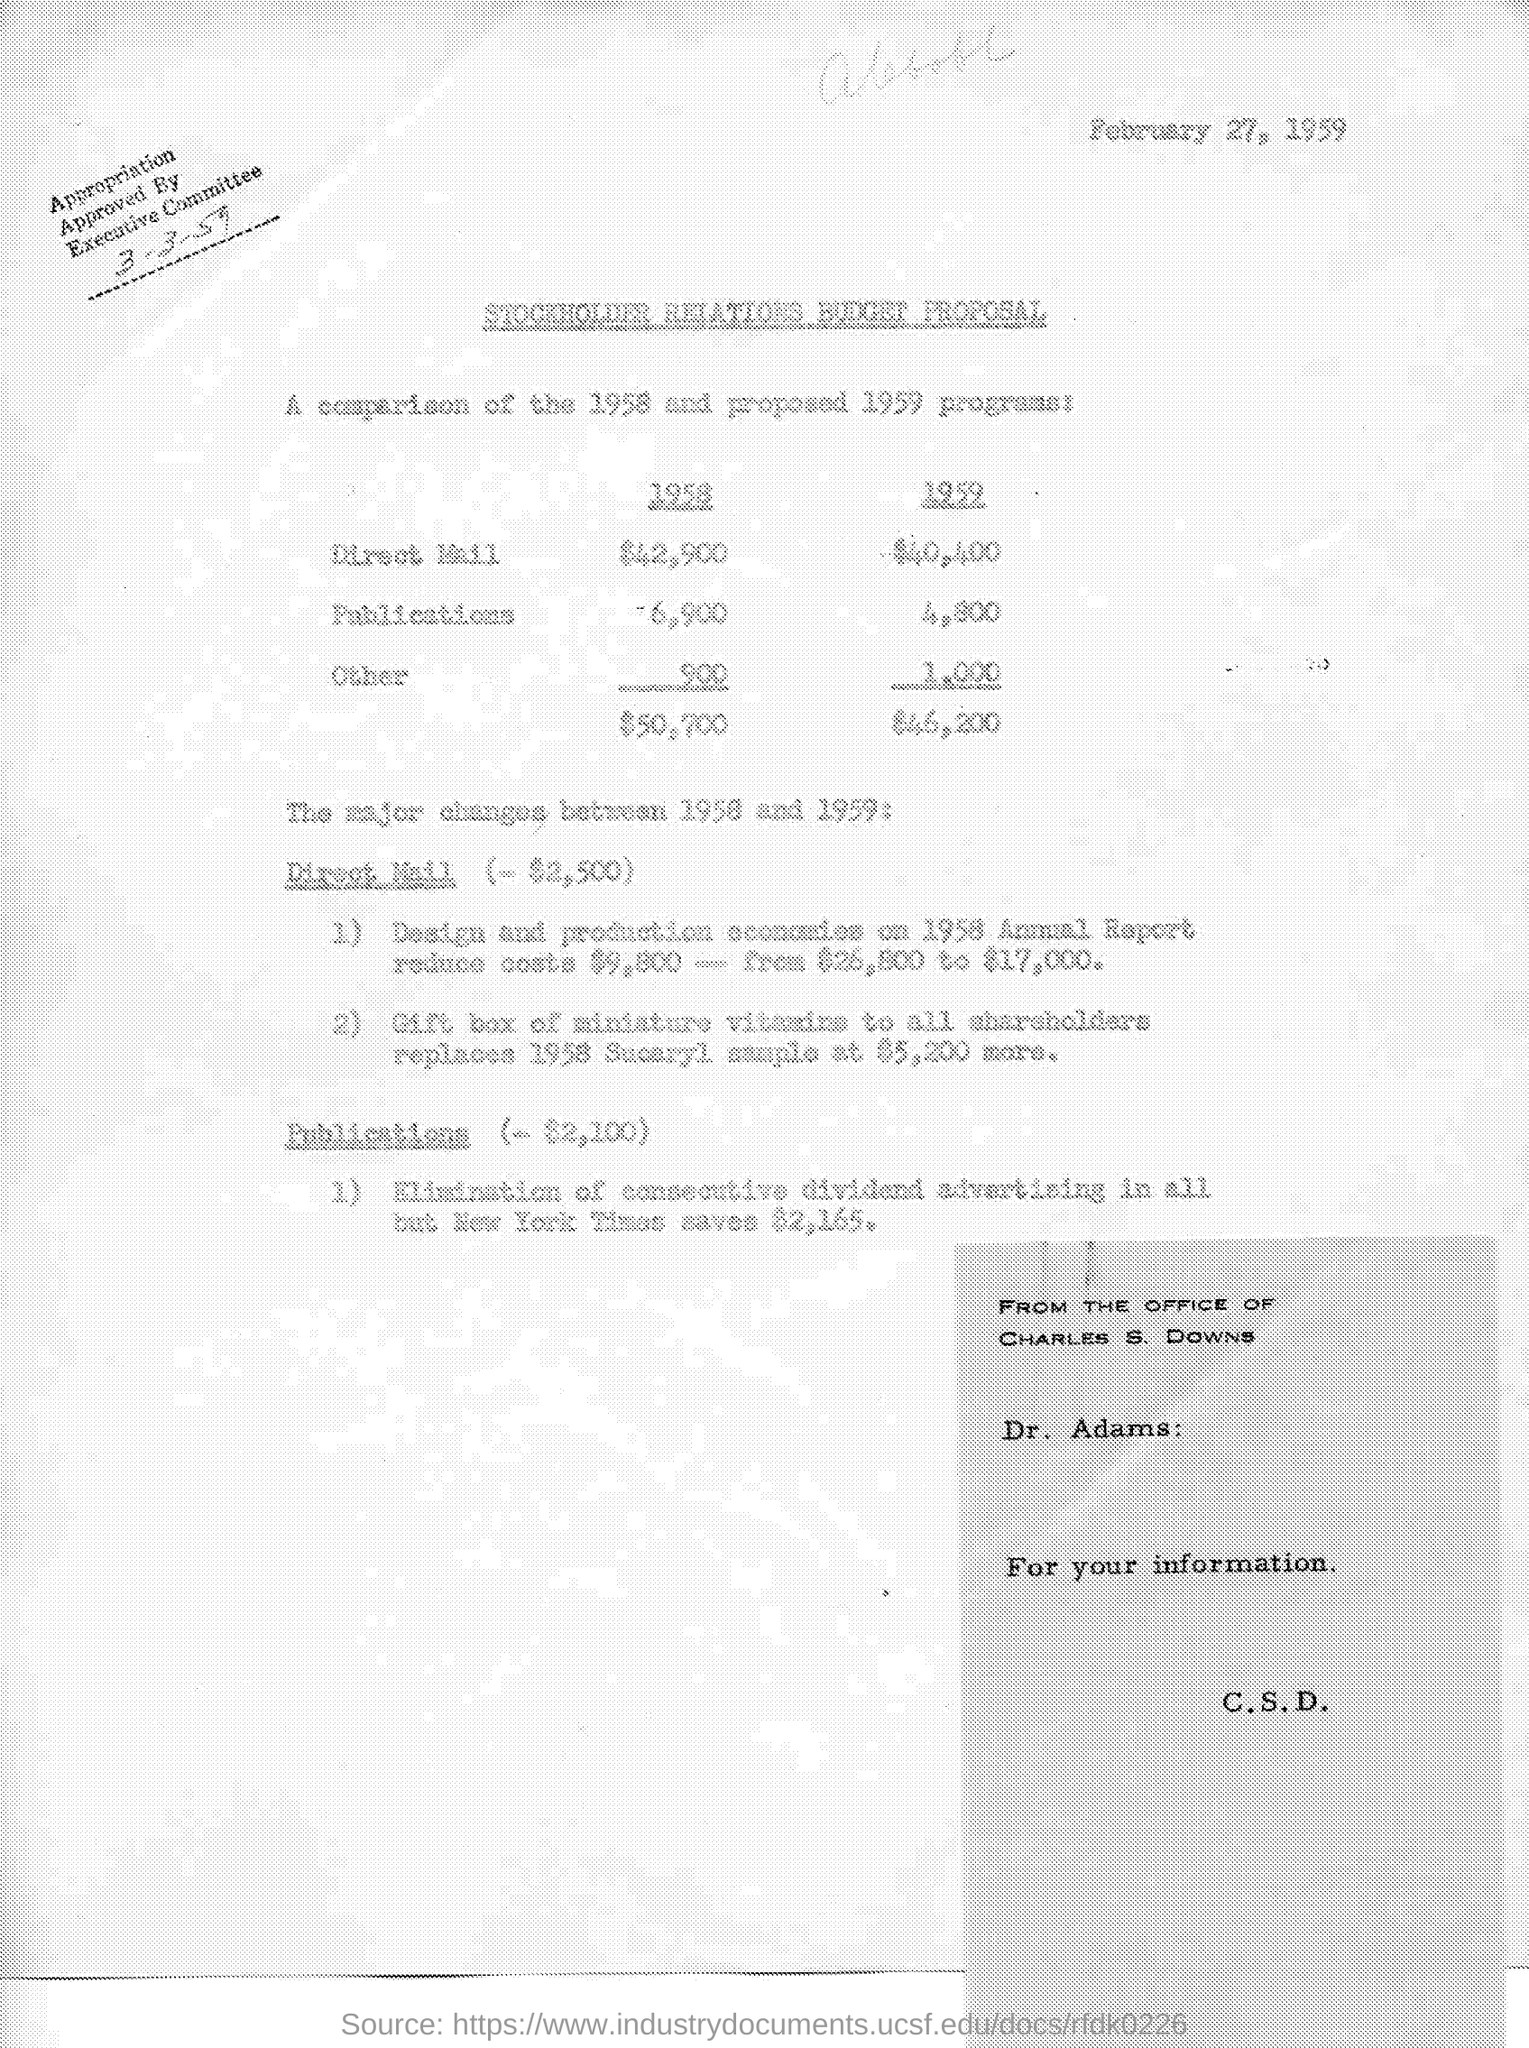Point out several critical features in this image. The date mentioned in the given page is February 27, 1959. The appropriation was approved by the executive committee. In the year 1959, the total budget amounted to $46,200. In the year 1958, the budget for direct mail was $42,900. In the year 1958, the total budget amounted to $50,700. 